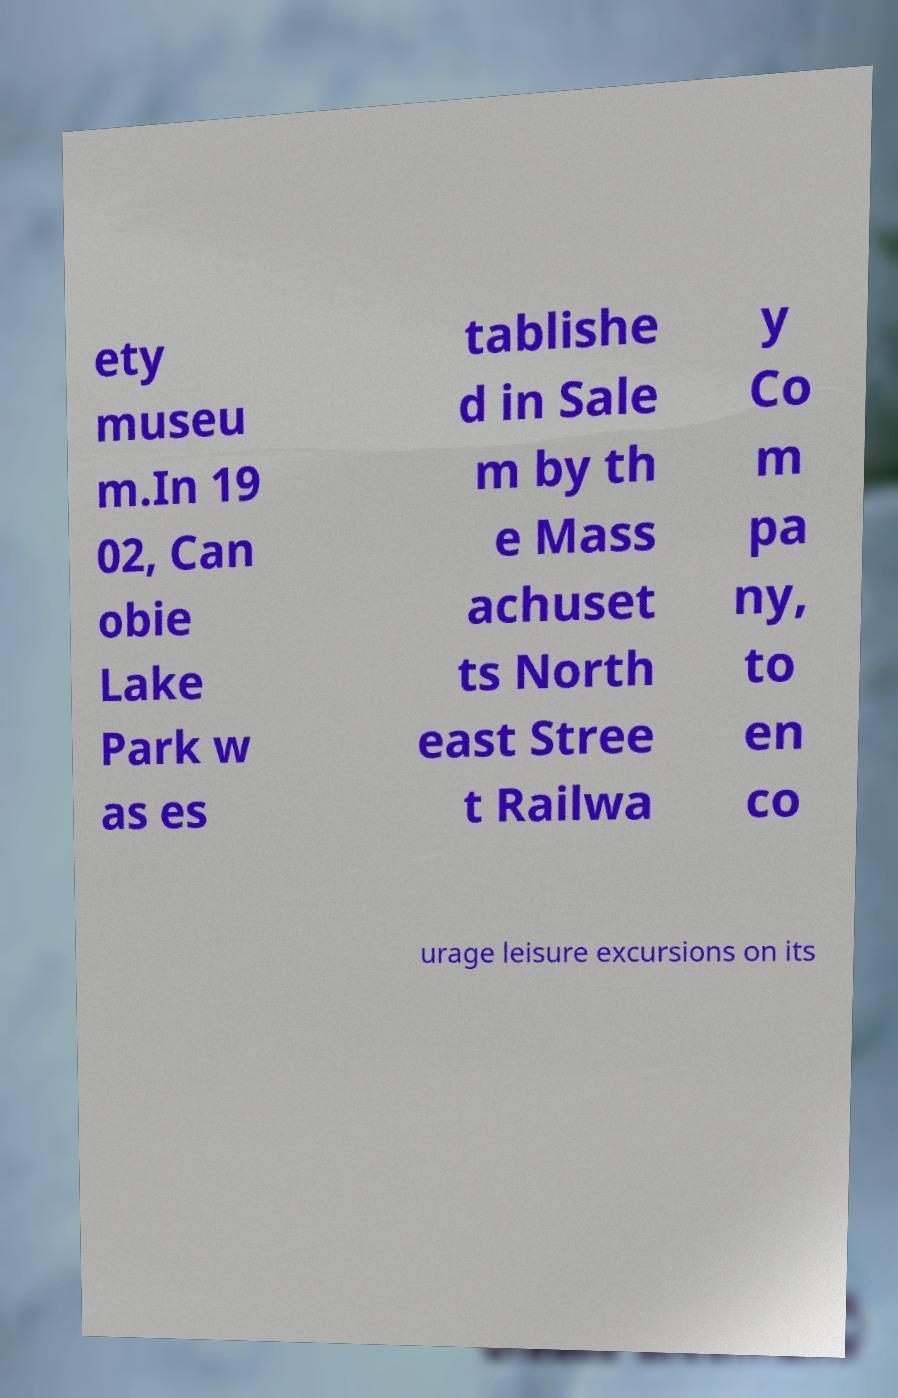Could you extract and type out the text from this image? ety museu m.In 19 02, Can obie Lake Park w as es tablishe d in Sale m by th e Mass achuset ts North east Stree t Railwa y Co m pa ny, to en co urage leisure excursions on its 